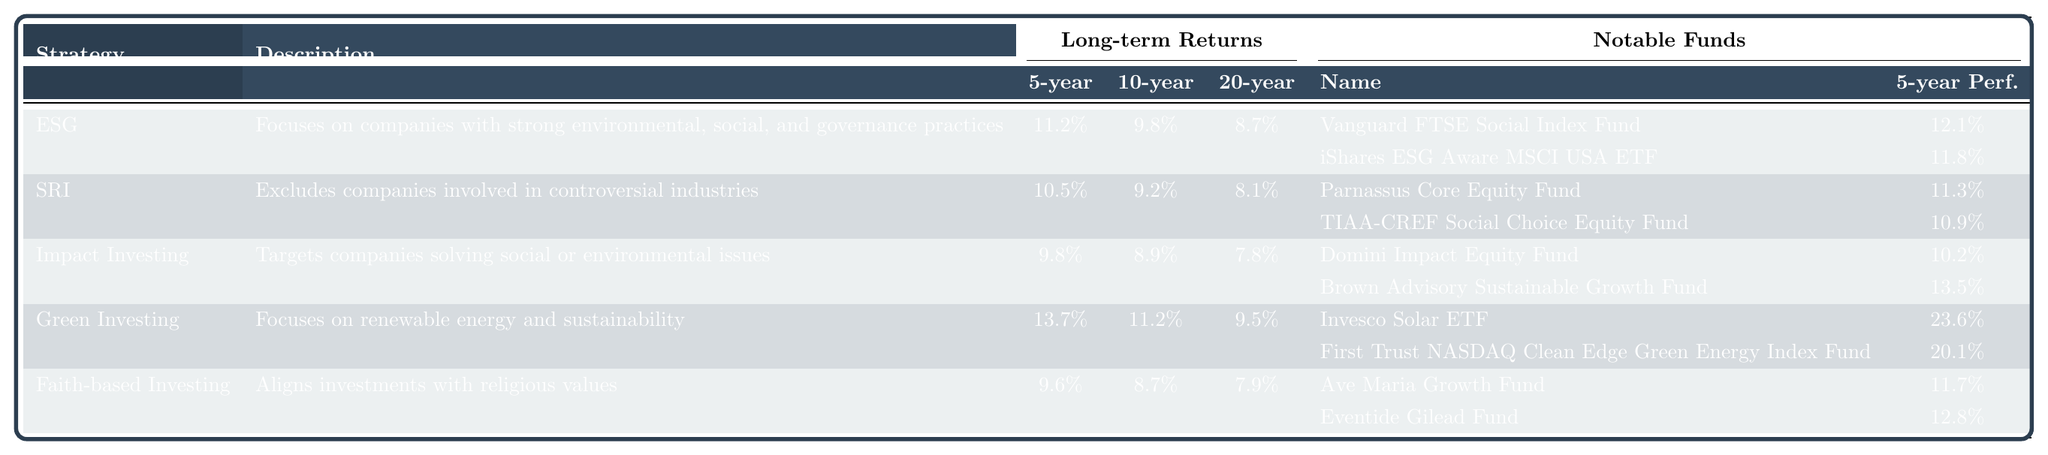What is the long-term return for the Green Investing strategy over 10 years? The 10-year return for Green Investing is listed in the table under the Long-term Returns section. It shows 11.2% for this strategy.
Answer: 11.2% Which ethical investment strategy has the highest 5-year return? The 5-year return for each strategy is compared in the Long-term Returns section of the table. Green Investing shows the highest return at 13.7%.
Answer: 13.7% Does the Socially Responsible Investing (SRI) strategy outperform the Impact Investing strategy over 20 years? For SRI, the 20-year return is 8.1%, while Impact Investing's return is 7.8%. Since 8.1% is greater than 7.8%, SRI outperforms Impact Investing over 20 years.
Answer: Yes What are the notable funds for the Environmental, Social, and Governance (ESG) strategy and their 5-year performances? The table provides the notable funds under the ESG strategy along with their 5-year performances. They are Vanguard FTSE Social Index Fund with 12.1% and iShares ESG Aware MSCI USA ETF with 11.8%.
Answer: Vanguard FTSE Social Index Fund (12.1%), iShares ESG Aware MSCI USA ETF (11.8%) What is the difference in 5-year returns between Green Investing and Faith-based Investing? The 5-year return for Green Investing is 13.7%, and for Faith-based Investing, it is 9.6%. To find the difference, subtract 9.6% from 13.7%, which equals 4.1%.
Answer: 4.1% Which investment strategy has the lowest long-term return over 20 years? The 20-year returns for each strategy are compared. Impact Investing has the lowest return at 7.8%.
Answer: Impact Investing (7.8%) Are the 10-year returns for both Faith-based Investing and Impact Investing the same? The 10-year return for Faith-based Investing is 8.7%, while for Impact Investing, it is 8.9%. Since these values are different, they are not the same.
Answer: No Which notable fund within the Green Investing strategy has the highest 5-year performance? The notable funds listed for Green Investing show that Invesco Solar ETF has a performance of 23.6%, which is the highest among the funds listed for this strategy.
Answer: Invesco Solar ETF (23.6%) What is the average 5-year performance for the funds listed under the Socially Responsible Investing (SRI) strategy? The 5-year performances for the SRI funds are 11.3% and 10.9%. To calculate the average, sum these values (11.3% + 10.9% = 22.2%) and divide by 2, leading to an average of 11.1%.
Answer: 11.1% Which strategy consistently shows the highest returns across all three long-term periods? By reviewing the long-term returns for each strategy, Green Investing has the highest returns in both the 5-year (13.7%) and 10-year (11.2%) periods. For the 20-year period, ESG is the highest (8.7%), but Green Investing remains strong overall.
Answer: Green Investing What is the relationship between 20-year returns and the types of ethical investment strategies? Examining the 20-year returns reveals a downward trend as we move from Green Investing (9.5%) to ESG (8.7%), then to SRI (8.1%), and finally to Impact Investing (7.8%). Generally, more reciprocally invested, ethical strategies display lower returns over a longer term.
Answer: Evident downward trend in returns 